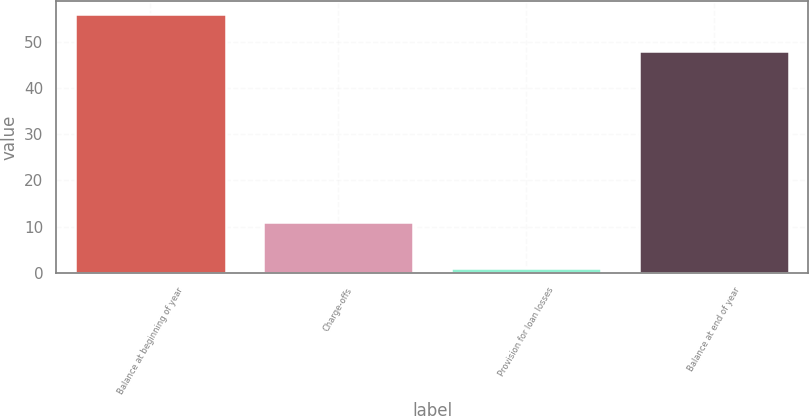Convert chart. <chart><loc_0><loc_0><loc_500><loc_500><bar_chart><fcel>Balance at beginning of year<fcel>Charge-offs<fcel>Provision for loan losses<fcel>Balance at end of year<nl><fcel>56<fcel>11<fcel>1<fcel>48<nl></chart> 